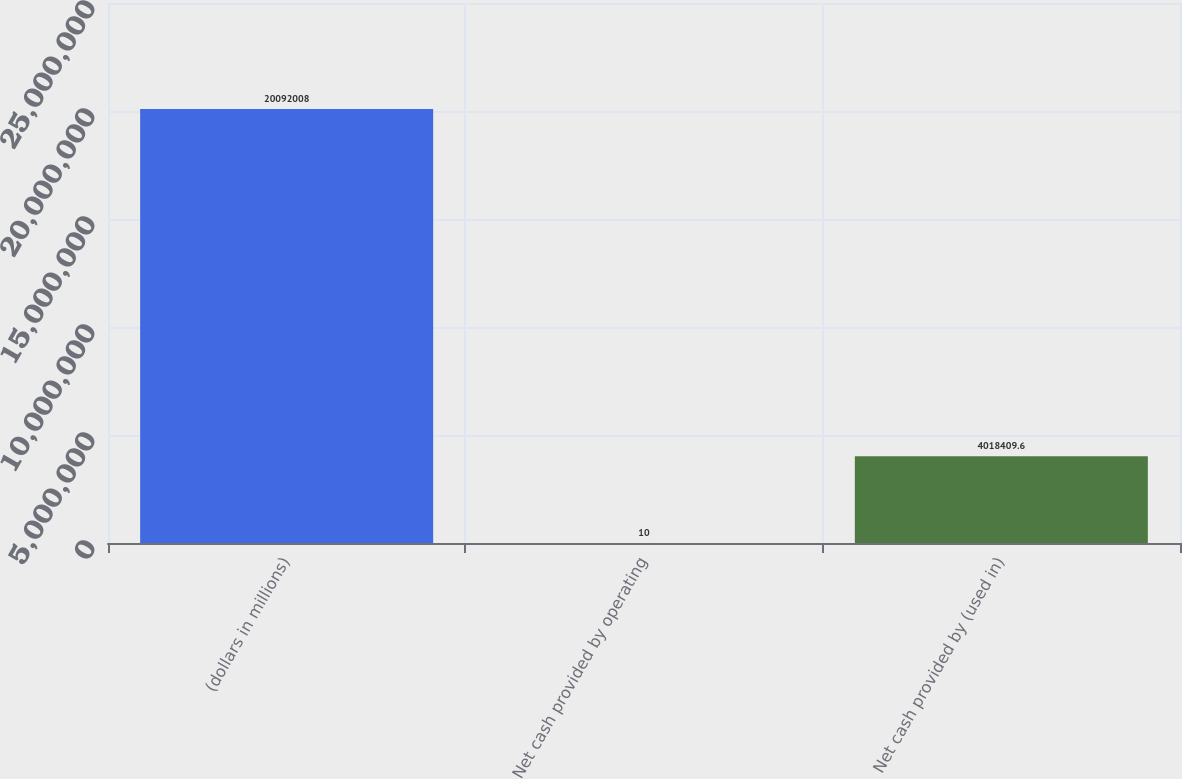Convert chart. <chart><loc_0><loc_0><loc_500><loc_500><bar_chart><fcel>(dollars in millions)<fcel>Net cash provided by operating<fcel>Net cash provided by (used in)<nl><fcel>2.0092e+07<fcel>10<fcel>4.01841e+06<nl></chart> 